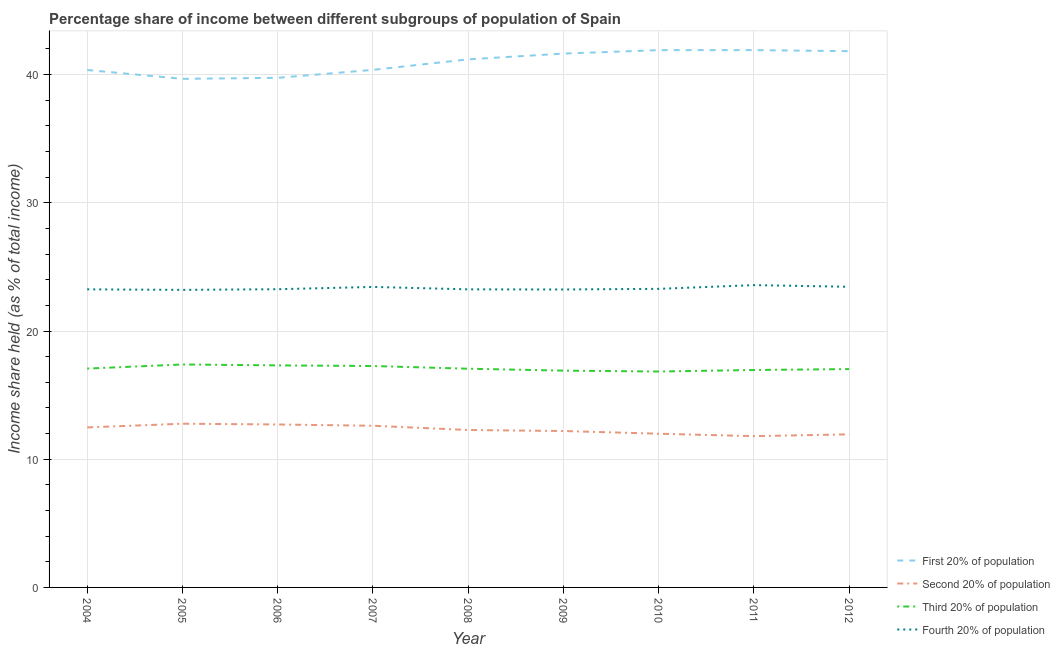Does the line corresponding to share of the income held by first 20% of the population intersect with the line corresponding to share of the income held by third 20% of the population?
Provide a short and direct response. No. Is the number of lines equal to the number of legend labels?
Ensure brevity in your answer.  Yes. What is the share of the income held by first 20% of the population in 2012?
Give a very brief answer. 41.83. Across all years, what is the maximum share of the income held by fourth 20% of the population?
Provide a short and direct response. 23.58. Across all years, what is the minimum share of the income held by third 20% of the population?
Offer a terse response. 16.84. In which year was the share of the income held by second 20% of the population maximum?
Offer a terse response. 2005. What is the total share of the income held by third 20% of the population in the graph?
Provide a succinct answer. 153.85. What is the difference between the share of the income held by first 20% of the population in 2007 and that in 2010?
Your response must be concise. -1.54. What is the difference between the share of the income held by third 20% of the population in 2008 and the share of the income held by first 20% of the population in 2010?
Provide a succinct answer. -24.85. What is the average share of the income held by third 20% of the population per year?
Offer a very short reply. 17.09. In the year 2011, what is the difference between the share of the income held by second 20% of the population and share of the income held by third 20% of the population?
Ensure brevity in your answer.  -5.16. In how many years, is the share of the income held by third 20% of the population greater than 4 %?
Provide a short and direct response. 9. What is the ratio of the share of the income held by third 20% of the population in 2004 to that in 2008?
Offer a very short reply. 1. Is the share of the income held by fourth 20% of the population in 2011 less than that in 2012?
Offer a very short reply. No. Is the difference between the share of the income held by second 20% of the population in 2006 and 2009 greater than the difference between the share of the income held by first 20% of the population in 2006 and 2009?
Your answer should be very brief. Yes. What is the difference between the highest and the second highest share of the income held by second 20% of the population?
Offer a terse response. 0.06. What is the difference between the highest and the lowest share of the income held by fourth 20% of the population?
Provide a succinct answer. 0.37. Is the sum of the share of the income held by first 20% of the population in 2006 and 2010 greater than the maximum share of the income held by third 20% of the population across all years?
Your answer should be very brief. Yes. Is it the case that in every year, the sum of the share of the income held by first 20% of the population and share of the income held by second 20% of the population is greater than the sum of share of the income held by fourth 20% of the population and share of the income held by third 20% of the population?
Keep it short and to the point. No. Does the share of the income held by third 20% of the population monotonically increase over the years?
Provide a succinct answer. No. How many lines are there?
Provide a short and direct response. 4. How many years are there in the graph?
Make the answer very short. 9. Does the graph contain any zero values?
Ensure brevity in your answer.  No. Does the graph contain grids?
Make the answer very short. Yes. Where does the legend appear in the graph?
Provide a short and direct response. Bottom right. What is the title of the graph?
Make the answer very short. Percentage share of income between different subgroups of population of Spain. What is the label or title of the X-axis?
Make the answer very short. Year. What is the label or title of the Y-axis?
Provide a succinct answer. Income share held (as % of total income). What is the Income share held (as % of total income) in First 20% of population in 2004?
Your answer should be very brief. 40.36. What is the Income share held (as % of total income) of Second 20% of population in 2004?
Keep it short and to the point. 12.48. What is the Income share held (as % of total income) in Third 20% of population in 2004?
Keep it short and to the point. 17.07. What is the Income share held (as % of total income) of Fourth 20% of population in 2004?
Provide a succinct answer. 23.25. What is the Income share held (as % of total income) in First 20% of population in 2005?
Keep it short and to the point. 39.67. What is the Income share held (as % of total income) of Second 20% of population in 2005?
Keep it short and to the point. 12.77. What is the Income share held (as % of total income) in Third 20% of population in 2005?
Offer a very short reply. 17.39. What is the Income share held (as % of total income) in Fourth 20% of population in 2005?
Make the answer very short. 23.21. What is the Income share held (as % of total income) in First 20% of population in 2006?
Your response must be concise. 39.75. What is the Income share held (as % of total income) of Second 20% of population in 2006?
Your answer should be very brief. 12.71. What is the Income share held (as % of total income) of Third 20% of population in 2006?
Your answer should be very brief. 17.32. What is the Income share held (as % of total income) of Fourth 20% of population in 2006?
Keep it short and to the point. 23.26. What is the Income share held (as % of total income) in First 20% of population in 2007?
Your answer should be compact. 40.37. What is the Income share held (as % of total income) of Second 20% of population in 2007?
Provide a short and direct response. 12.61. What is the Income share held (as % of total income) in Third 20% of population in 2007?
Provide a short and direct response. 17.27. What is the Income share held (as % of total income) of Fourth 20% of population in 2007?
Offer a terse response. 23.44. What is the Income share held (as % of total income) of First 20% of population in 2008?
Make the answer very short. 41.19. What is the Income share held (as % of total income) of Second 20% of population in 2008?
Provide a short and direct response. 12.28. What is the Income share held (as % of total income) of Third 20% of population in 2008?
Make the answer very short. 17.06. What is the Income share held (as % of total income) of Fourth 20% of population in 2008?
Keep it short and to the point. 23.25. What is the Income share held (as % of total income) of First 20% of population in 2009?
Offer a very short reply. 41.64. What is the Income share held (as % of total income) in Third 20% of population in 2009?
Your answer should be compact. 16.91. What is the Income share held (as % of total income) in Fourth 20% of population in 2009?
Offer a terse response. 23.24. What is the Income share held (as % of total income) in First 20% of population in 2010?
Your response must be concise. 41.91. What is the Income share held (as % of total income) of Second 20% of population in 2010?
Give a very brief answer. 11.99. What is the Income share held (as % of total income) in Third 20% of population in 2010?
Make the answer very short. 16.84. What is the Income share held (as % of total income) of Fourth 20% of population in 2010?
Offer a terse response. 23.29. What is the Income share held (as % of total income) of First 20% of population in 2011?
Your answer should be compact. 41.91. What is the Income share held (as % of total income) of Second 20% of population in 2011?
Make the answer very short. 11.8. What is the Income share held (as % of total income) of Third 20% of population in 2011?
Ensure brevity in your answer.  16.96. What is the Income share held (as % of total income) of Fourth 20% of population in 2011?
Make the answer very short. 23.58. What is the Income share held (as % of total income) of First 20% of population in 2012?
Keep it short and to the point. 41.83. What is the Income share held (as % of total income) of Second 20% of population in 2012?
Ensure brevity in your answer.  11.94. What is the Income share held (as % of total income) in Third 20% of population in 2012?
Your answer should be very brief. 17.03. What is the Income share held (as % of total income) in Fourth 20% of population in 2012?
Your answer should be very brief. 23.45. Across all years, what is the maximum Income share held (as % of total income) in First 20% of population?
Offer a very short reply. 41.91. Across all years, what is the maximum Income share held (as % of total income) of Second 20% of population?
Your answer should be compact. 12.77. Across all years, what is the maximum Income share held (as % of total income) of Third 20% of population?
Offer a very short reply. 17.39. Across all years, what is the maximum Income share held (as % of total income) in Fourth 20% of population?
Make the answer very short. 23.58. Across all years, what is the minimum Income share held (as % of total income) of First 20% of population?
Ensure brevity in your answer.  39.67. Across all years, what is the minimum Income share held (as % of total income) in Second 20% of population?
Your response must be concise. 11.8. Across all years, what is the minimum Income share held (as % of total income) in Third 20% of population?
Provide a succinct answer. 16.84. Across all years, what is the minimum Income share held (as % of total income) in Fourth 20% of population?
Keep it short and to the point. 23.21. What is the total Income share held (as % of total income) in First 20% of population in the graph?
Your response must be concise. 368.63. What is the total Income share held (as % of total income) in Second 20% of population in the graph?
Keep it short and to the point. 110.78. What is the total Income share held (as % of total income) of Third 20% of population in the graph?
Ensure brevity in your answer.  153.85. What is the total Income share held (as % of total income) of Fourth 20% of population in the graph?
Keep it short and to the point. 209.97. What is the difference between the Income share held (as % of total income) of First 20% of population in 2004 and that in 2005?
Your answer should be compact. 0.69. What is the difference between the Income share held (as % of total income) in Second 20% of population in 2004 and that in 2005?
Keep it short and to the point. -0.29. What is the difference between the Income share held (as % of total income) in Third 20% of population in 2004 and that in 2005?
Provide a succinct answer. -0.32. What is the difference between the Income share held (as % of total income) in First 20% of population in 2004 and that in 2006?
Keep it short and to the point. 0.61. What is the difference between the Income share held (as % of total income) in Second 20% of population in 2004 and that in 2006?
Provide a short and direct response. -0.23. What is the difference between the Income share held (as % of total income) in Fourth 20% of population in 2004 and that in 2006?
Offer a terse response. -0.01. What is the difference between the Income share held (as % of total income) of First 20% of population in 2004 and that in 2007?
Ensure brevity in your answer.  -0.01. What is the difference between the Income share held (as % of total income) in Second 20% of population in 2004 and that in 2007?
Keep it short and to the point. -0.13. What is the difference between the Income share held (as % of total income) in Third 20% of population in 2004 and that in 2007?
Provide a short and direct response. -0.2. What is the difference between the Income share held (as % of total income) of Fourth 20% of population in 2004 and that in 2007?
Your response must be concise. -0.19. What is the difference between the Income share held (as % of total income) of First 20% of population in 2004 and that in 2008?
Keep it short and to the point. -0.83. What is the difference between the Income share held (as % of total income) in First 20% of population in 2004 and that in 2009?
Your response must be concise. -1.28. What is the difference between the Income share held (as % of total income) in Second 20% of population in 2004 and that in 2009?
Your answer should be compact. 0.28. What is the difference between the Income share held (as % of total income) of Third 20% of population in 2004 and that in 2009?
Offer a very short reply. 0.16. What is the difference between the Income share held (as % of total income) of Fourth 20% of population in 2004 and that in 2009?
Offer a very short reply. 0.01. What is the difference between the Income share held (as % of total income) of First 20% of population in 2004 and that in 2010?
Offer a terse response. -1.55. What is the difference between the Income share held (as % of total income) in Second 20% of population in 2004 and that in 2010?
Your answer should be compact. 0.49. What is the difference between the Income share held (as % of total income) of Third 20% of population in 2004 and that in 2010?
Give a very brief answer. 0.23. What is the difference between the Income share held (as % of total income) of Fourth 20% of population in 2004 and that in 2010?
Keep it short and to the point. -0.04. What is the difference between the Income share held (as % of total income) of First 20% of population in 2004 and that in 2011?
Ensure brevity in your answer.  -1.55. What is the difference between the Income share held (as % of total income) of Second 20% of population in 2004 and that in 2011?
Your answer should be compact. 0.68. What is the difference between the Income share held (as % of total income) in Third 20% of population in 2004 and that in 2011?
Make the answer very short. 0.11. What is the difference between the Income share held (as % of total income) in Fourth 20% of population in 2004 and that in 2011?
Give a very brief answer. -0.33. What is the difference between the Income share held (as % of total income) in First 20% of population in 2004 and that in 2012?
Keep it short and to the point. -1.47. What is the difference between the Income share held (as % of total income) in Second 20% of population in 2004 and that in 2012?
Provide a short and direct response. 0.54. What is the difference between the Income share held (as % of total income) of Third 20% of population in 2004 and that in 2012?
Make the answer very short. 0.04. What is the difference between the Income share held (as % of total income) of First 20% of population in 2005 and that in 2006?
Your answer should be compact. -0.08. What is the difference between the Income share held (as % of total income) of Third 20% of population in 2005 and that in 2006?
Make the answer very short. 0.07. What is the difference between the Income share held (as % of total income) in Fourth 20% of population in 2005 and that in 2006?
Offer a very short reply. -0.05. What is the difference between the Income share held (as % of total income) in Second 20% of population in 2005 and that in 2007?
Ensure brevity in your answer.  0.16. What is the difference between the Income share held (as % of total income) in Third 20% of population in 2005 and that in 2007?
Your response must be concise. 0.12. What is the difference between the Income share held (as % of total income) in Fourth 20% of population in 2005 and that in 2007?
Your answer should be compact. -0.23. What is the difference between the Income share held (as % of total income) of First 20% of population in 2005 and that in 2008?
Provide a succinct answer. -1.52. What is the difference between the Income share held (as % of total income) of Second 20% of population in 2005 and that in 2008?
Offer a terse response. 0.49. What is the difference between the Income share held (as % of total income) of Third 20% of population in 2005 and that in 2008?
Keep it short and to the point. 0.33. What is the difference between the Income share held (as % of total income) of Fourth 20% of population in 2005 and that in 2008?
Your response must be concise. -0.04. What is the difference between the Income share held (as % of total income) in First 20% of population in 2005 and that in 2009?
Offer a terse response. -1.97. What is the difference between the Income share held (as % of total income) of Second 20% of population in 2005 and that in 2009?
Provide a succinct answer. 0.57. What is the difference between the Income share held (as % of total income) in Third 20% of population in 2005 and that in 2009?
Ensure brevity in your answer.  0.48. What is the difference between the Income share held (as % of total income) of Fourth 20% of population in 2005 and that in 2009?
Give a very brief answer. -0.03. What is the difference between the Income share held (as % of total income) of First 20% of population in 2005 and that in 2010?
Give a very brief answer. -2.24. What is the difference between the Income share held (as % of total income) of Second 20% of population in 2005 and that in 2010?
Offer a very short reply. 0.78. What is the difference between the Income share held (as % of total income) in Third 20% of population in 2005 and that in 2010?
Keep it short and to the point. 0.55. What is the difference between the Income share held (as % of total income) in Fourth 20% of population in 2005 and that in 2010?
Your answer should be very brief. -0.08. What is the difference between the Income share held (as % of total income) in First 20% of population in 2005 and that in 2011?
Provide a short and direct response. -2.24. What is the difference between the Income share held (as % of total income) in Third 20% of population in 2005 and that in 2011?
Give a very brief answer. 0.43. What is the difference between the Income share held (as % of total income) of Fourth 20% of population in 2005 and that in 2011?
Ensure brevity in your answer.  -0.37. What is the difference between the Income share held (as % of total income) of First 20% of population in 2005 and that in 2012?
Your answer should be compact. -2.16. What is the difference between the Income share held (as % of total income) in Second 20% of population in 2005 and that in 2012?
Make the answer very short. 0.83. What is the difference between the Income share held (as % of total income) in Third 20% of population in 2005 and that in 2012?
Give a very brief answer. 0.36. What is the difference between the Income share held (as % of total income) in Fourth 20% of population in 2005 and that in 2012?
Your answer should be compact. -0.24. What is the difference between the Income share held (as % of total income) in First 20% of population in 2006 and that in 2007?
Your answer should be compact. -0.62. What is the difference between the Income share held (as % of total income) in Third 20% of population in 2006 and that in 2007?
Your response must be concise. 0.05. What is the difference between the Income share held (as % of total income) of Fourth 20% of population in 2006 and that in 2007?
Your answer should be compact. -0.18. What is the difference between the Income share held (as % of total income) in First 20% of population in 2006 and that in 2008?
Ensure brevity in your answer.  -1.44. What is the difference between the Income share held (as % of total income) of Second 20% of population in 2006 and that in 2008?
Your answer should be compact. 0.43. What is the difference between the Income share held (as % of total income) in Third 20% of population in 2006 and that in 2008?
Your response must be concise. 0.26. What is the difference between the Income share held (as % of total income) of First 20% of population in 2006 and that in 2009?
Your response must be concise. -1.89. What is the difference between the Income share held (as % of total income) of Second 20% of population in 2006 and that in 2009?
Your response must be concise. 0.51. What is the difference between the Income share held (as % of total income) of Third 20% of population in 2006 and that in 2009?
Ensure brevity in your answer.  0.41. What is the difference between the Income share held (as % of total income) of Fourth 20% of population in 2006 and that in 2009?
Your answer should be compact. 0.02. What is the difference between the Income share held (as % of total income) of First 20% of population in 2006 and that in 2010?
Your answer should be very brief. -2.16. What is the difference between the Income share held (as % of total income) of Second 20% of population in 2006 and that in 2010?
Your answer should be very brief. 0.72. What is the difference between the Income share held (as % of total income) in Third 20% of population in 2006 and that in 2010?
Make the answer very short. 0.48. What is the difference between the Income share held (as % of total income) of Fourth 20% of population in 2006 and that in 2010?
Your answer should be compact. -0.03. What is the difference between the Income share held (as % of total income) of First 20% of population in 2006 and that in 2011?
Keep it short and to the point. -2.16. What is the difference between the Income share held (as % of total income) of Second 20% of population in 2006 and that in 2011?
Ensure brevity in your answer.  0.91. What is the difference between the Income share held (as % of total income) in Third 20% of population in 2006 and that in 2011?
Provide a succinct answer. 0.36. What is the difference between the Income share held (as % of total income) in Fourth 20% of population in 2006 and that in 2011?
Make the answer very short. -0.32. What is the difference between the Income share held (as % of total income) of First 20% of population in 2006 and that in 2012?
Provide a short and direct response. -2.08. What is the difference between the Income share held (as % of total income) in Second 20% of population in 2006 and that in 2012?
Offer a very short reply. 0.77. What is the difference between the Income share held (as % of total income) of Third 20% of population in 2006 and that in 2012?
Ensure brevity in your answer.  0.29. What is the difference between the Income share held (as % of total income) in Fourth 20% of population in 2006 and that in 2012?
Your answer should be very brief. -0.19. What is the difference between the Income share held (as % of total income) in First 20% of population in 2007 and that in 2008?
Offer a terse response. -0.82. What is the difference between the Income share held (as % of total income) in Second 20% of population in 2007 and that in 2008?
Your response must be concise. 0.33. What is the difference between the Income share held (as % of total income) of Third 20% of population in 2007 and that in 2008?
Ensure brevity in your answer.  0.21. What is the difference between the Income share held (as % of total income) of Fourth 20% of population in 2007 and that in 2008?
Make the answer very short. 0.19. What is the difference between the Income share held (as % of total income) in First 20% of population in 2007 and that in 2009?
Your answer should be compact. -1.27. What is the difference between the Income share held (as % of total income) in Second 20% of population in 2007 and that in 2009?
Your answer should be compact. 0.41. What is the difference between the Income share held (as % of total income) in Third 20% of population in 2007 and that in 2009?
Your answer should be compact. 0.36. What is the difference between the Income share held (as % of total income) of Fourth 20% of population in 2007 and that in 2009?
Your response must be concise. 0.2. What is the difference between the Income share held (as % of total income) of First 20% of population in 2007 and that in 2010?
Your answer should be very brief. -1.54. What is the difference between the Income share held (as % of total income) of Second 20% of population in 2007 and that in 2010?
Your answer should be compact. 0.62. What is the difference between the Income share held (as % of total income) of Third 20% of population in 2007 and that in 2010?
Your answer should be compact. 0.43. What is the difference between the Income share held (as % of total income) in Fourth 20% of population in 2007 and that in 2010?
Your answer should be very brief. 0.15. What is the difference between the Income share held (as % of total income) of First 20% of population in 2007 and that in 2011?
Offer a very short reply. -1.54. What is the difference between the Income share held (as % of total income) in Second 20% of population in 2007 and that in 2011?
Your answer should be compact. 0.81. What is the difference between the Income share held (as % of total income) in Third 20% of population in 2007 and that in 2011?
Your response must be concise. 0.31. What is the difference between the Income share held (as % of total income) of Fourth 20% of population in 2007 and that in 2011?
Offer a terse response. -0.14. What is the difference between the Income share held (as % of total income) in First 20% of population in 2007 and that in 2012?
Your response must be concise. -1.46. What is the difference between the Income share held (as % of total income) of Second 20% of population in 2007 and that in 2012?
Ensure brevity in your answer.  0.67. What is the difference between the Income share held (as % of total income) of Third 20% of population in 2007 and that in 2012?
Your answer should be very brief. 0.24. What is the difference between the Income share held (as % of total income) in Fourth 20% of population in 2007 and that in 2012?
Make the answer very short. -0.01. What is the difference between the Income share held (as % of total income) of First 20% of population in 2008 and that in 2009?
Make the answer very short. -0.45. What is the difference between the Income share held (as % of total income) of Third 20% of population in 2008 and that in 2009?
Your answer should be very brief. 0.15. What is the difference between the Income share held (as % of total income) in Fourth 20% of population in 2008 and that in 2009?
Give a very brief answer. 0.01. What is the difference between the Income share held (as % of total income) in First 20% of population in 2008 and that in 2010?
Offer a very short reply. -0.72. What is the difference between the Income share held (as % of total income) in Second 20% of population in 2008 and that in 2010?
Your answer should be very brief. 0.29. What is the difference between the Income share held (as % of total income) of Third 20% of population in 2008 and that in 2010?
Keep it short and to the point. 0.22. What is the difference between the Income share held (as % of total income) of Fourth 20% of population in 2008 and that in 2010?
Offer a very short reply. -0.04. What is the difference between the Income share held (as % of total income) in First 20% of population in 2008 and that in 2011?
Make the answer very short. -0.72. What is the difference between the Income share held (as % of total income) of Second 20% of population in 2008 and that in 2011?
Your answer should be compact. 0.48. What is the difference between the Income share held (as % of total income) in Fourth 20% of population in 2008 and that in 2011?
Your answer should be compact. -0.33. What is the difference between the Income share held (as % of total income) in First 20% of population in 2008 and that in 2012?
Give a very brief answer. -0.64. What is the difference between the Income share held (as % of total income) of Second 20% of population in 2008 and that in 2012?
Keep it short and to the point. 0.34. What is the difference between the Income share held (as % of total income) of Third 20% of population in 2008 and that in 2012?
Keep it short and to the point. 0.03. What is the difference between the Income share held (as % of total income) in Fourth 20% of population in 2008 and that in 2012?
Provide a succinct answer. -0.2. What is the difference between the Income share held (as % of total income) of First 20% of population in 2009 and that in 2010?
Make the answer very short. -0.27. What is the difference between the Income share held (as % of total income) in Second 20% of population in 2009 and that in 2010?
Provide a succinct answer. 0.21. What is the difference between the Income share held (as % of total income) of Third 20% of population in 2009 and that in 2010?
Your response must be concise. 0.07. What is the difference between the Income share held (as % of total income) of First 20% of population in 2009 and that in 2011?
Make the answer very short. -0.27. What is the difference between the Income share held (as % of total income) of Fourth 20% of population in 2009 and that in 2011?
Offer a very short reply. -0.34. What is the difference between the Income share held (as % of total income) in First 20% of population in 2009 and that in 2012?
Offer a terse response. -0.19. What is the difference between the Income share held (as % of total income) of Second 20% of population in 2009 and that in 2012?
Your answer should be compact. 0.26. What is the difference between the Income share held (as % of total income) of Third 20% of population in 2009 and that in 2012?
Ensure brevity in your answer.  -0.12. What is the difference between the Income share held (as % of total income) of Fourth 20% of population in 2009 and that in 2012?
Your answer should be compact. -0.21. What is the difference between the Income share held (as % of total income) of Second 20% of population in 2010 and that in 2011?
Your answer should be very brief. 0.19. What is the difference between the Income share held (as % of total income) in Third 20% of population in 2010 and that in 2011?
Provide a short and direct response. -0.12. What is the difference between the Income share held (as % of total income) in Fourth 20% of population in 2010 and that in 2011?
Offer a very short reply. -0.29. What is the difference between the Income share held (as % of total income) in Second 20% of population in 2010 and that in 2012?
Your answer should be compact. 0.05. What is the difference between the Income share held (as % of total income) of Third 20% of population in 2010 and that in 2012?
Ensure brevity in your answer.  -0.19. What is the difference between the Income share held (as % of total income) of Fourth 20% of population in 2010 and that in 2012?
Provide a succinct answer. -0.16. What is the difference between the Income share held (as % of total income) of Second 20% of population in 2011 and that in 2012?
Your answer should be compact. -0.14. What is the difference between the Income share held (as % of total income) in Third 20% of population in 2011 and that in 2012?
Provide a short and direct response. -0.07. What is the difference between the Income share held (as % of total income) in Fourth 20% of population in 2011 and that in 2012?
Provide a short and direct response. 0.13. What is the difference between the Income share held (as % of total income) in First 20% of population in 2004 and the Income share held (as % of total income) in Second 20% of population in 2005?
Provide a short and direct response. 27.59. What is the difference between the Income share held (as % of total income) in First 20% of population in 2004 and the Income share held (as % of total income) in Third 20% of population in 2005?
Your answer should be very brief. 22.97. What is the difference between the Income share held (as % of total income) in First 20% of population in 2004 and the Income share held (as % of total income) in Fourth 20% of population in 2005?
Your answer should be very brief. 17.15. What is the difference between the Income share held (as % of total income) of Second 20% of population in 2004 and the Income share held (as % of total income) of Third 20% of population in 2005?
Give a very brief answer. -4.91. What is the difference between the Income share held (as % of total income) of Second 20% of population in 2004 and the Income share held (as % of total income) of Fourth 20% of population in 2005?
Keep it short and to the point. -10.73. What is the difference between the Income share held (as % of total income) of Third 20% of population in 2004 and the Income share held (as % of total income) of Fourth 20% of population in 2005?
Provide a succinct answer. -6.14. What is the difference between the Income share held (as % of total income) of First 20% of population in 2004 and the Income share held (as % of total income) of Second 20% of population in 2006?
Ensure brevity in your answer.  27.65. What is the difference between the Income share held (as % of total income) in First 20% of population in 2004 and the Income share held (as % of total income) in Third 20% of population in 2006?
Ensure brevity in your answer.  23.04. What is the difference between the Income share held (as % of total income) in Second 20% of population in 2004 and the Income share held (as % of total income) in Third 20% of population in 2006?
Your response must be concise. -4.84. What is the difference between the Income share held (as % of total income) in Second 20% of population in 2004 and the Income share held (as % of total income) in Fourth 20% of population in 2006?
Ensure brevity in your answer.  -10.78. What is the difference between the Income share held (as % of total income) in Third 20% of population in 2004 and the Income share held (as % of total income) in Fourth 20% of population in 2006?
Your answer should be compact. -6.19. What is the difference between the Income share held (as % of total income) of First 20% of population in 2004 and the Income share held (as % of total income) of Second 20% of population in 2007?
Make the answer very short. 27.75. What is the difference between the Income share held (as % of total income) of First 20% of population in 2004 and the Income share held (as % of total income) of Third 20% of population in 2007?
Your answer should be compact. 23.09. What is the difference between the Income share held (as % of total income) of First 20% of population in 2004 and the Income share held (as % of total income) of Fourth 20% of population in 2007?
Offer a terse response. 16.92. What is the difference between the Income share held (as % of total income) of Second 20% of population in 2004 and the Income share held (as % of total income) of Third 20% of population in 2007?
Offer a very short reply. -4.79. What is the difference between the Income share held (as % of total income) of Second 20% of population in 2004 and the Income share held (as % of total income) of Fourth 20% of population in 2007?
Provide a succinct answer. -10.96. What is the difference between the Income share held (as % of total income) in Third 20% of population in 2004 and the Income share held (as % of total income) in Fourth 20% of population in 2007?
Offer a terse response. -6.37. What is the difference between the Income share held (as % of total income) of First 20% of population in 2004 and the Income share held (as % of total income) of Second 20% of population in 2008?
Your answer should be compact. 28.08. What is the difference between the Income share held (as % of total income) in First 20% of population in 2004 and the Income share held (as % of total income) in Third 20% of population in 2008?
Ensure brevity in your answer.  23.3. What is the difference between the Income share held (as % of total income) in First 20% of population in 2004 and the Income share held (as % of total income) in Fourth 20% of population in 2008?
Offer a very short reply. 17.11. What is the difference between the Income share held (as % of total income) in Second 20% of population in 2004 and the Income share held (as % of total income) in Third 20% of population in 2008?
Your response must be concise. -4.58. What is the difference between the Income share held (as % of total income) of Second 20% of population in 2004 and the Income share held (as % of total income) of Fourth 20% of population in 2008?
Your answer should be very brief. -10.77. What is the difference between the Income share held (as % of total income) of Third 20% of population in 2004 and the Income share held (as % of total income) of Fourth 20% of population in 2008?
Give a very brief answer. -6.18. What is the difference between the Income share held (as % of total income) of First 20% of population in 2004 and the Income share held (as % of total income) of Second 20% of population in 2009?
Ensure brevity in your answer.  28.16. What is the difference between the Income share held (as % of total income) of First 20% of population in 2004 and the Income share held (as % of total income) of Third 20% of population in 2009?
Your response must be concise. 23.45. What is the difference between the Income share held (as % of total income) of First 20% of population in 2004 and the Income share held (as % of total income) of Fourth 20% of population in 2009?
Your answer should be very brief. 17.12. What is the difference between the Income share held (as % of total income) of Second 20% of population in 2004 and the Income share held (as % of total income) of Third 20% of population in 2009?
Your answer should be very brief. -4.43. What is the difference between the Income share held (as % of total income) of Second 20% of population in 2004 and the Income share held (as % of total income) of Fourth 20% of population in 2009?
Your answer should be compact. -10.76. What is the difference between the Income share held (as % of total income) of Third 20% of population in 2004 and the Income share held (as % of total income) of Fourth 20% of population in 2009?
Provide a succinct answer. -6.17. What is the difference between the Income share held (as % of total income) in First 20% of population in 2004 and the Income share held (as % of total income) in Second 20% of population in 2010?
Your response must be concise. 28.37. What is the difference between the Income share held (as % of total income) in First 20% of population in 2004 and the Income share held (as % of total income) in Third 20% of population in 2010?
Ensure brevity in your answer.  23.52. What is the difference between the Income share held (as % of total income) in First 20% of population in 2004 and the Income share held (as % of total income) in Fourth 20% of population in 2010?
Your answer should be compact. 17.07. What is the difference between the Income share held (as % of total income) of Second 20% of population in 2004 and the Income share held (as % of total income) of Third 20% of population in 2010?
Your response must be concise. -4.36. What is the difference between the Income share held (as % of total income) of Second 20% of population in 2004 and the Income share held (as % of total income) of Fourth 20% of population in 2010?
Give a very brief answer. -10.81. What is the difference between the Income share held (as % of total income) of Third 20% of population in 2004 and the Income share held (as % of total income) of Fourth 20% of population in 2010?
Offer a terse response. -6.22. What is the difference between the Income share held (as % of total income) in First 20% of population in 2004 and the Income share held (as % of total income) in Second 20% of population in 2011?
Give a very brief answer. 28.56. What is the difference between the Income share held (as % of total income) in First 20% of population in 2004 and the Income share held (as % of total income) in Third 20% of population in 2011?
Your answer should be compact. 23.4. What is the difference between the Income share held (as % of total income) of First 20% of population in 2004 and the Income share held (as % of total income) of Fourth 20% of population in 2011?
Your answer should be compact. 16.78. What is the difference between the Income share held (as % of total income) of Second 20% of population in 2004 and the Income share held (as % of total income) of Third 20% of population in 2011?
Offer a terse response. -4.48. What is the difference between the Income share held (as % of total income) in Third 20% of population in 2004 and the Income share held (as % of total income) in Fourth 20% of population in 2011?
Your answer should be very brief. -6.51. What is the difference between the Income share held (as % of total income) in First 20% of population in 2004 and the Income share held (as % of total income) in Second 20% of population in 2012?
Offer a terse response. 28.42. What is the difference between the Income share held (as % of total income) in First 20% of population in 2004 and the Income share held (as % of total income) in Third 20% of population in 2012?
Provide a short and direct response. 23.33. What is the difference between the Income share held (as % of total income) in First 20% of population in 2004 and the Income share held (as % of total income) in Fourth 20% of population in 2012?
Your answer should be very brief. 16.91. What is the difference between the Income share held (as % of total income) in Second 20% of population in 2004 and the Income share held (as % of total income) in Third 20% of population in 2012?
Make the answer very short. -4.55. What is the difference between the Income share held (as % of total income) of Second 20% of population in 2004 and the Income share held (as % of total income) of Fourth 20% of population in 2012?
Your answer should be very brief. -10.97. What is the difference between the Income share held (as % of total income) in Third 20% of population in 2004 and the Income share held (as % of total income) in Fourth 20% of population in 2012?
Offer a very short reply. -6.38. What is the difference between the Income share held (as % of total income) of First 20% of population in 2005 and the Income share held (as % of total income) of Second 20% of population in 2006?
Your answer should be compact. 26.96. What is the difference between the Income share held (as % of total income) in First 20% of population in 2005 and the Income share held (as % of total income) in Third 20% of population in 2006?
Keep it short and to the point. 22.35. What is the difference between the Income share held (as % of total income) in First 20% of population in 2005 and the Income share held (as % of total income) in Fourth 20% of population in 2006?
Ensure brevity in your answer.  16.41. What is the difference between the Income share held (as % of total income) in Second 20% of population in 2005 and the Income share held (as % of total income) in Third 20% of population in 2006?
Your answer should be very brief. -4.55. What is the difference between the Income share held (as % of total income) of Second 20% of population in 2005 and the Income share held (as % of total income) of Fourth 20% of population in 2006?
Provide a short and direct response. -10.49. What is the difference between the Income share held (as % of total income) of Third 20% of population in 2005 and the Income share held (as % of total income) of Fourth 20% of population in 2006?
Offer a terse response. -5.87. What is the difference between the Income share held (as % of total income) in First 20% of population in 2005 and the Income share held (as % of total income) in Second 20% of population in 2007?
Your answer should be compact. 27.06. What is the difference between the Income share held (as % of total income) of First 20% of population in 2005 and the Income share held (as % of total income) of Third 20% of population in 2007?
Your answer should be compact. 22.4. What is the difference between the Income share held (as % of total income) in First 20% of population in 2005 and the Income share held (as % of total income) in Fourth 20% of population in 2007?
Your answer should be compact. 16.23. What is the difference between the Income share held (as % of total income) in Second 20% of population in 2005 and the Income share held (as % of total income) in Third 20% of population in 2007?
Your response must be concise. -4.5. What is the difference between the Income share held (as % of total income) in Second 20% of population in 2005 and the Income share held (as % of total income) in Fourth 20% of population in 2007?
Make the answer very short. -10.67. What is the difference between the Income share held (as % of total income) of Third 20% of population in 2005 and the Income share held (as % of total income) of Fourth 20% of population in 2007?
Offer a very short reply. -6.05. What is the difference between the Income share held (as % of total income) in First 20% of population in 2005 and the Income share held (as % of total income) in Second 20% of population in 2008?
Ensure brevity in your answer.  27.39. What is the difference between the Income share held (as % of total income) of First 20% of population in 2005 and the Income share held (as % of total income) of Third 20% of population in 2008?
Offer a terse response. 22.61. What is the difference between the Income share held (as % of total income) of First 20% of population in 2005 and the Income share held (as % of total income) of Fourth 20% of population in 2008?
Give a very brief answer. 16.42. What is the difference between the Income share held (as % of total income) in Second 20% of population in 2005 and the Income share held (as % of total income) in Third 20% of population in 2008?
Your answer should be compact. -4.29. What is the difference between the Income share held (as % of total income) in Second 20% of population in 2005 and the Income share held (as % of total income) in Fourth 20% of population in 2008?
Provide a short and direct response. -10.48. What is the difference between the Income share held (as % of total income) in Third 20% of population in 2005 and the Income share held (as % of total income) in Fourth 20% of population in 2008?
Ensure brevity in your answer.  -5.86. What is the difference between the Income share held (as % of total income) in First 20% of population in 2005 and the Income share held (as % of total income) in Second 20% of population in 2009?
Ensure brevity in your answer.  27.47. What is the difference between the Income share held (as % of total income) in First 20% of population in 2005 and the Income share held (as % of total income) in Third 20% of population in 2009?
Your response must be concise. 22.76. What is the difference between the Income share held (as % of total income) of First 20% of population in 2005 and the Income share held (as % of total income) of Fourth 20% of population in 2009?
Provide a succinct answer. 16.43. What is the difference between the Income share held (as % of total income) of Second 20% of population in 2005 and the Income share held (as % of total income) of Third 20% of population in 2009?
Make the answer very short. -4.14. What is the difference between the Income share held (as % of total income) of Second 20% of population in 2005 and the Income share held (as % of total income) of Fourth 20% of population in 2009?
Offer a very short reply. -10.47. What is the difference between the Income share held (as % of total income) in Third 20% of population in 2005 and the Income share held (as % of total income) in Fourth 20% of population in 2009?
Offer a very short reply. -5.85. What is the difference between the Income share held (as % of total income) in First 20% of population in 2005 and the Income share held (as % of total income) in Second 20% of population in 2010?
Offer a terse response. 27.68. What is the difference between the Income share held (as % of total income) in First 20% of population in 2005 and the Income share held (as % of total income) in Third 20% of population in 2010?
Your answer should be very brief. 22.83. What is the difference between the Income share held (as % of total income) of First 20% of population in 2005 and the Income share held (as % of total income) of Fourth 20% of population in 2010?
Provide a succinct answer. 16.38. What is the difference between the Income share held (as % of total income) in Second 20% of population in 2005 and the Income share held (as % of total income) in Third 20% of population in 2010?
Offer a terse response. -4.07. What is the difference between the Income share held (as % of total income) of Second 20% of population in 2005 and the Income share held (as % of total income) of Fourth 20% of population in 2010?
Provide a succinct answer. -10.52. What is the difference between the Income share held (as % of total income) of Third 20% of population in 2005 and the Income share held (as % of total income) of Fourth 20% of population in 2010?
Make the answer very short. -5.9. What is the difference between the Income share held (as % of total income) of First 20% of population in 2005 and the Income share held (as % of total income) of Second 20% of population in 2011?
Your answer should be very brief. 27.87. What is the difference between the Income share held (as % of total income) of First 20% of population in 2005 and the Income share held (as % of total income) of Third 20% of population in 2011?
Give a very brief answer. 22.71. What is the difference between the Income share held (as % of total income) in First 20% of population in 2005 and the Income share held (as % of total income) in Fourth 20% of population in 2011?
Give a very brief answer. 16.09. What is the difference between the Income share held (as % of total income) in Second 20% of population in 2005 and the Income share held (as % of total income) in Third 20% of population in 2011?
Give a very brief answer. -4.19. What is the difference between the Income share held (as % of total income) of Second 20% of population in 2005 and the Income share held (as % of total income) of Fourth 20% of population in 2011?
Your response must be concise. -10.81. What is the difference between the Income share held (as % of total income) in Third 20% of population in 2005 and the Income share held (as % of total income) in Fourth 20% of population in 2011?
Give a very brief answer. -6.19. What is the difference between the Income share held (as % of total income) in First 20% of population in 2005 and the Income share held (as % of total income) in Second 20% of population in 2012?
Your answer should be compact. 27.73. What is the difference between the Income share held (as % of total income) in First 20% of population in 2005 and the Income share held (as % of total income) in Third 20% of population in 2012?
Your answer should be compact. 22.64. What is the difference between the Income share held (as % of total income) of First 20% of population in 2005 and the Income share held (as % of total income) of Fourth 20% of population in 2012?
Offer a terse response. 16.22. What is the difference between the Income share held (as % of total income) in Second 20% of population in 2005 and the Income share held (as % of total income) in Third 20% of population in 2012?
Make the answer very short. -4.26. What is the difference between the Income share held (as % of total income) in Second 20% of population in 2005 and the Income share held (as % of total income) in Fourth 20% of population in 2012?
Give a very brief answer. -10.68. What is the difference between the Income share held (as % of total income) of Third 20% of population in 2005 and the Income share held (as % of total income) of Fourth 20% of population in 2012?
Your response must be concise. -6.06. What is the difference between the Income share held (as % of total income) in First 20% of population in 2006 and the Income share held (as % of total income) in Second 20% of population in 2007?
Your response must be concise. 27.14. What is the difference between the Income share held (as % of total income) in First 20% of population in 2006 and the Income share held (as % of total income) in Third 20% of population in 2007?
Ensure brevity in your answer.  22.48. What is the difference between the Income share held (as % of total income) of First 20% of population in 2006 and the Income share held (as % of total income) of Fourth 20% of population in 2007?
Keep it short and to the point. 16.31. What is the difference between the Income share held (as % of total income) in Second 20% of population in 2006 and the Income share held (as % of total income) in Third 20% of population in 2007?
Ensure brevity in your answer.  -4.56. What is the difference between the Income share held (as % of total income) of Second 20% of population in 2006 and the Income share held (as % of total income) of Fourth 20% of population in 2007?
Your answer should be very brief. -10.73. What is the difference between the Income share held (as % of total income) in Third 20% of population in 2006 and the Income share held (as % of total income) in Fourth 20% of population in 2007?
Keep it short and to the point. -6.12. What is the difference between the Income share held (as % of total income) of First 20% of population in 2006 and the Income share held (as % of total income) of Second 20% of population in 2008?
Ensure brevity in your answer.  27.47. What is the difference between the Income share held (as % of total income) in First 20% of population in 2006 and the Income share held (as % of total income) in Third 20% of population in 2008?
Provide a short and direct response. 22.69. What is the difference between the Income share held (as % of total income) in Second 20% of population in 2006 and the Income share held (as % of total income) in Third 20% of population in 2008?
Ensure brevity in your answer.  -4.35. What is the difference between the Income share held (as % of total income) in Second 20% of population in 2006 and the Income share held (as % of total income) in Fourth 20% of population in 2008?
Provide a short and direct response. -10.54. What is the difference between the Income share held (as % of total income) in Third 20% of population in 2006 and the Income share held (as % of total income) in Fourth 20% of population in 2008?
Give a very brief answer. -5.93. What is the difference between the Income share held (as % of total income) of First 20% of population in 2006 and the Income share held (as % of total income) of Second 20% of population in 2009?
Ensure brevity in your answer.  27.55. What is the difference between the Income share held (as % of total income) of First 20% of population in 2006 and the Income share held (as % of total income) of Third 20% of population in 2009?
Offer a very short reply. 22.84. What is the difference between the Income share held (as % of total income) of First 20% of population in 2006 and the Income share held (as % of total income) of Fourth 20% of population in 2009?
Make the answer very short. 16.51. What is the difference between the Income share held (as % of total income) of Second 20% of population in 2006 and the Income share held (as % of total income) of Third 20% of population in 2009?
Your response must be concise. -4.2. What is the difference between the Income share held (as % of total income) of Second 20% of population in 2006 and the Income share held (as % of total income) of Fourth 20% of population in 2009?
Provide a succinct answer. -10.53. What is the difference between the Income share held (as % of total income) of Third 20% of population in 2006 and the Income share held (as % of total income) of Fourth 20% of population in 2009?
Offer a very short reply. -5.92. What is the difference between the Income share held (as % of total income) in First 20% of population in 2006 and the Income share held (as % of total income) in Second 20% of population in 2010?
Your answer should be compact. 27.76. What is the difference between the Income share held (as % of total income) of First 20% of population in 2006 and the Income share held (as % of total income) of Third 20% of population in 2010?
Offer a very short reply. 22.91. What is the difference between the Income share held (as % of total income) in First 20% of population in 2006 and the Income share held (as % of total income) in Fourth 20% of population in 2010?
Offer a terse response. 16.46. What is the difference between the Income share held (as % of total income) of Second 20% of population in 2006 and the Income share held (as % of total income) of Third 20% of population in 2010?
Provide a short and direct response. -4.13. What is the difference between the Income share held (as % of total income) in Second 20% of population in 2006 and the Income share held (as % of total income) in Fourth 20% of population in 2010?
Provide a short and direct response. -10.58. What is the difference between the Income share held (as % of total income) of Third 20% of population in 2006 and the Income share held (as % of total income) of Fourth 20% of population in 2010?
Offer a very short reply. -5.97. What is the difference between the Income share held (as % of total income) of First 20% of population in 2006 and the Income share held (as % of total income) of Second 20% of population in 2011?
Your response must be concise. 27.95. What is the difference between the Income share held (as % of total income) of First 20% of population in 2006 and the Income share held (as % of total income) of Third 20% of population in 2011?
Give a very brief answer. 22.79. What is the difference between the Income share held (as % of total income) in First 20% of population in 2006 and the Income share held (as % of total income) in Fourth 20% of population in 2011?
Offer a very short reply. 16.17. What is the difference between the Income share held (as % of total income) of Second 20% of population in 2006 and the Income share held (as % of total income) of Third 20% of population in 2011?
Provide a short and direct response. -4.25. What is the difference between the Income share held (as % of total income) in Second 20% of population in 2006 and the Income share held (as % of total income) in Fourth 20% of population in 2011?
Ensure brevity in your answer.  -10.87. What is the difference between the Income share held (as % of total income) of Third 20% of population in 2006 and the Income share held (as % of total income) of Fourth 20% of population in 2011?
Your response must be concise. -6.26. What is the difference between the Income share held (as % of total income) of First 20% of population in 2006 and the Income share held (as % of total income) of Second 20% of population in 2012?
Keep it short and to the point. 27.81. What is the difference between the Income share held (as % of total income) of First 20% of population in 2006 and the Income share held (as % of total income) of Third 20% of population in 2012?
Provide a succinct answer. 22.72. What is the difference between the Income share held (as % of total income) in First 20% of population in 2006 and the Income share held (as % of total income) in Fourth 20% of population in 2012?
Ensure brevity in your answer.  16.3. What is the difference between the Income share held (as % of total income) of Second 20% of population in 2006 and the Income share held (as % of total income) of Third 20% of population in 2012?
Your answer should be compact. -4.32. What is the difference between the Income share held (as % of total income) in Second 20% of population in 2006 and the Income share held (as % of total income) in Fourth 20% of population in 2012?
Provide a short and direct response. -10.74. What is the difference between the Income share held (as % of total income) of Third 20% of population in 2006 and the Income share held (as % of total income) of Fourth 20% of population in 2012?
Your answer should be compact. -6.13. What is the difference between the Income share held (as % of total income) of First 20% of population in 2007 and the Income share held (as % of total income) of Second 20% of population in 2008?
Offer a very short reply. 28.09. What is the difference between the Income share held (as % of total income) of First 20% of population in 2007 and the Income share held (as % of total income) of Third 20% of population in 2008?
Provide a succinct answer. 23.31. What is the difference between the Income share held (as % of total income) of First 20% of population in 2007 and the Income share held (as % of total income) of Fourth 20% of population in 2008?
Provide a succinct answer. 17.12. What is the difference between the Income share held (as % of total income) of Second 20% of population in 2007 and the Income share held (as % of total income) of Third 20% of population in 2008?
Provide a succinct answer. -4.45. What is the difference between the Income share held (as % of total income) in Second 20% of population in 2007 and the Income share held (as % of total income) in Fourth 20% of population in 2008?
Offer a very short reply. -10.64. What is the difference between the Income share held (as % of total income) in Third 20% of population in 2007 and the Income share held (as % of total income) in Fourth 20% of population in 2008?
Offer a terse response. -5.98. What is the difference between the Income share held (as % of total income) of First 20% of population in 2007 and the Income share held (as % of total income) of Second 20% of population in 2009?
Keep it short and to the point. 28.17. What is the difference between the Income share held (as % of total income) in First 20% of population in 2007 and the Income share held (as % of total income) in Third 20% of population in 2009?
Your answer should be very brief. 23.46. What is the difference between the Income share held (as % of total income) of First 20% of population in 2007 and the Income share held (as % of total income) of Fourth 20% of population in 2009?
Offer a very short reply. 17.13. What is the difference between the Income share held (as % of total income) in Second 20% of population in 2007 and the Income share held (as % of total income) in Third 20% of population in 2009?
Offer a terse response. -4.3. What is the difference between the Income share held (as % of total income) in Second 20% of population in 2007 and the Income share held (as % of total income) in Fourth 20% of population in 2009?
Make the answer very short. -10.63. What is the difference between the Income share held (as % of total income) in Third 20% of population in 2007 and the Income share held (as % of total income) in Fourth 20% of population in 2009?
Keep it short and to the point. -5.97. What is the difference between the Income share held (as % of total income) of First 20% of population in 2007 and the Income share held (as % of total income) of Second 20% of population in 2010?
Offer a very short reply. 28.38. What is the difference between the Income share held (as % of total income) in First 20% of population in 2007 and the Income share held (as % of total income) in Third 20% of population in 2010?
Make the answer very short. 23.53. What is the difference between the Income share held (as % of total income) of First 20% of population in 2007 and the Income share held (as % of total income) of Fourth 20% of population in 2010?
Provide a short and direct response. 17.08. What is the difference between the Income share held (as % of total income) of Second 20% of population in 2007 and the Income share held (as % of total income) of Third 20% of population in 2010?
Ensure brevity in your answer.  -4.23. What is the difference between the Income share held (as % of total income) in Second 20% of population in 2007 and the Income share held (as % of total income) in Fourth 20% of population in 2010?
Your answer should be very brief. -10.68. What is the difference between the Income share held (as % of total income) of Third 20% of population in 2007 and the Income share held (as % of total income) of Fourth 20% of population in 2010?
Make the answer very short. -6.02. What is the difference between the Income share held (as % of total income) of First 20% of population in 2007 and the Income share held (as % of total income) of Second 20% of population in 2011?
Offer a terse response. 28.57. What is the difference between the Income share held (as % of total income) of First 20% of population in 2007 and the Income share held (as % of total income) of Third 20% of population in 2011?
Keep it short and to the point. 23.41. What is the difference between the Income share held (as % of total income) in First 20% of population in 2007 and the Income share held (as % of total income) in Fourth 20% of population in 2011?
Keep it short and to the point. 16.79. What is the difference between the Income share held (as % of total income) in Second 20% of population in 2007 and the Income share held (as % of total income) in Third 20% of population in 2011?
Make the answer very short. -4.35. What is the difference between the Income share held (as % of total income) in Second 20% of population in 2007 and the Income share held (as % of total income) in Fourth 20% of population in 2011?
Offer a terse response. -10.97. What is the difference between the Income share held (as % of total income) in Third 20% of population in 2007 and the Income share held (as % of total income) in Fourth 20% of population in 2011?
Your answer should be compact. -6.31. What is the difference between the Income share held (as % of total income) in First 20% of population in 2007 and the Income share held (as % of total income) in Second 20% of population in 2012?
Give a very brief answer. 28.43. What is the difference between the Income share held (as % of total income) in First 20% of population in 2007 and the Income share held (as % of total income) in Third 20% of population in 2012?
Your answer should be very brief. 23.34. What is the difference between the Income share held (as % of total income) of First 20% of population in 2007 and the Income share held (as % of total income) of Fourth 20% of population in 2012?
Your answer should be very brief. 16.92. What is the difference between the Income share held (as % of total income) in Second 20% of population in 2007 and the Income share held (as % of total income) in Third 20% of population in 2012?
Your response must be concise. -4.42. What is the difference between the Income share held (as % of total income) in Second 20% of population in 2007 and the Income share held (as % of total income) in Fourth 20% of population in 2012?
Keep it short and to the point. -10.84. What is the difference between the Income share held (as % of total income) of Third 20% of population in 2007 and the Income share held (as % of total income) of Fourth 20% of population in 2012?
Ensure brevity in your answer.  -6.18. What is the difference between the Income share held (as % of total income) of First 20% of population in 2008 and the Income share held (as % of total income) of Second 20% of population in 2009?
Provide a succinct answer. 28.99. What is the difference between the Income share held (as % of total income) in First 20% of population in 2008 and the Income share held (as % of total income) in Third 20% of population in 2009?
Your answer should be very brief. 24.28. What is the difference between the Income share held (as % of total income) in First 20% of population in 2008 and the Income share held (as % of total income) in Fourth 20% of population in 2009?
Ensure brevity in your answer.  17.95. What is the difference between the Income share held (as % of total income) of Second 20% of population in 2008 and the Income share held (as % of total income) of Third 20% of population in 2009?
Give a very brief answer. -4.63. What is the difference between the Income share held (as % of total income) in Second 20% of population in 2008 and the Income share held (as % of total income) in Fourth 20% of population in 2009?
Your response must be concise. -10.96. What is the difference between the Income share held (as % of total income) in Third 20% of population in 2008 and the Income share held (as % of total income) in Fourth 20% of population in 2009?
Keep it short and to the point. -6.18. What is the difference between the Income share held (as % of total income) of First 20% of population in 2008 and the Income share held (as % of total income) of Second 20% of population in 2010?
Ensure brevity in your answer.  29.2. What is the difference between the Income share held (as % of total income) of First 20% of population in 2008 and the Income share held (as % of total income) of Third 20% of population in 2010?
Ensure brevity in your answer.  24.35. What is the difference between the Income share held (as % of total income) in First 20% of population in 2008 and the Income share held (as % of total income) in Fourth 20% of population in 2010?
Your answer should be very brief. 17.9. What is the difference between the Income share held (as % of total income) of Second 20% of population in 2008 and the Income share held (as % of total income) of Third 20% of population in 2010?
Give a very brief answer. -4.56. What is the difference between the Income share held (as % of total income) in Second 20% of population in 2008 and the Income share held (as % of total income) in Fourth 20% of population in 2010?
Your answer should be very brief. -11.01. What is the difference between the Income share held (as % of total income) of Third 20% of population in 2008 and the Income share held (as % of total income) of Fourth 20% of population in 2010?
Provide a short and direct response. -6.23. What is the difference between the Income share held (as % of total income) in First 20% of population in 2008 and the Income share held (as % of total income) in Second 20% of population in 2011?
Provide a short and direct response. 29.39. What is the difference between the Income share held (as % of total income) of First 20% of population in 2008 and the Income share held (as % of total income) of Third 20% of population in 2011?
Provide a short and direct response. 24.23. What is the difference between the Income share held (as % of total income) of First 20% of population in 2008 and the Income share held (as % of total income) of Fourth 20% of population in 2011?
Your answer should be very brief. 17.61. What is the difference between the Income share held (as % of total income) in Second 20% of population in 2008 and the Income share held (as % of total income) in Third 20% of population in 2011?
Your answer should be very brief. -4.68. What is the difference between the Income share held (as % of total income) of Third 20% of population in 2008 and the Income share held (as % of total income) of Fourth 20% of population in 2011?
Your answer should be very brief. -6.52. What is the difference between the Income share held (as % of total income) in First 20% of population in 2008 and the Income share held (as % of total income) in Second 20% of population in 2012?
Offer a terse response. 29.25. What is the difference between the Income share held (as % of total income) of First 20% of population in 2008 and the Income share held (as % of total income) of Third 20% of population in 2012?
Give a very brief answer. 24.16. What is the difference between the Income share held (as % of total income) of First 20% of population in 2008 and the Income share held (as % of total income) of Fourth 20% of population in 2012?
Offer a terse response. 17.74. What is the difference between the Income share held (as % of total income) of Second 20% of population in 2008 and the Income share held (as % of total income) of Third 20% of population in 2012?
Ensure brevity in your answer.  -4.75. What is the difference between the Income share held (as % of total income) of Second 20% of population in 2008 and the Income share held (as % of total income) of Fourth 20% of population in 2012?
Your answer should be compact. -11.17. What is the difference between the Income share held (as % of total income) of Third 20% of population in 2008 and the Income share held (as % of total income) of Fourth 20% of population in 2012?
Keep it short and to the point. -6.39. What is the difference between the Income share held (as % of total income) in First 20% of population in 2009 and the Income share held (as % of total income) in Second 20% of population in 2010?
Your answer should be compact. 29.65. What is the difference between the Income share held (as % of total income) of First 20% of population in 2009 and the Income share held (as % of total income) of Third 20% of population in 2010?
Your answer should be compact. 24.8. What is the difference between the Income share held (as % of total income) of First 20% of population in 2009 and the Income share held (as % of total income) of Fourth 20% of population in 2010?
Offer a very short reply. 18.35. What is the difference between the Income share held (as % of total income) in Second 20% of population in 2009 and the Income share held (as % of total income) in Third 20% of population in 2010?
Provide a succinct answer. -4.64. What is the difference between the Income share held (as % of total income) of Second 20% of population in 2009 and the Income share held (as % of total income) of Fourth 20% of population in 2010?
Provide a succinct answer. -11.09. What is the difference between the Income share held (as % of total income) of Third 20% of population in 2009 and the Income share held (as % of total income) of Fourth 20% of population in 2010?
Make the answer very short. -6.38. What is the difference between the Income share held (as % of total income) in First 20% of population in 2009 and the Income share held (as % of total income) in Second 20% of population in 2011?
Provide a short and direct response. 29.84. What is the difference between the Income share held (as % of total income) in First 20% of population in 2009 and the Income share held (as % of total income) in Third 20% of population in 2011?
Offer a very short reply. 24.68. What is the difference between the Income share held (as % of total income) of First 20% of population in 2009 and the Income share held (as % of total income) of Fourth 20% of population in 2011?
Your answer should be very brief. 18.06. What is the difference between the Income share held (as % of total income) in Second 20% of population in 2009 and the Income share held (as % of total income) in Third 20% of population in 2011?
Give a very brief answer. -4.76. What is the difference between the Income share held (as % of total income) of Second 20% of population in 2009 and the Income share held (as % of total income) of Fourth 20% of population in 2011?
Provide a succinct answer. -11.38. What is the difference between the Income share held (as % of total income) in Third 20% of population in 2009 and the Income share held (as % of total income) in Fourth 20% of population in 2011?
Offer a very short reply. -6.67. What is the difference between the Income share held (as % of total income) in First 20% of population in 2009 and the Income share held (as % of total income) in Second 20% of population in 2012?
Keep it short and to the point. 29.7. What is the difference between the Income share held (as % of total income) in First 20% of population in 2009 and the Income share held (as % of total income) in Third 20% of population in 2012?
Provide a succinct answer. 24.61. What is the difference between the Income share held (as % of total income) in First 20% of population in 2009 and the Income share held (as % of total income) in Fourth 20% of population in 2012?
Provide a succinct answer. 18.19. What is the difference between the Income share held (as % of total income) in Second 20% of population in 2009 and the Income share held (as % of total income) in Third 20% of population in 2012?
Make the answer very short. -4.83. What is the difference between the Income share held (as % of total income) in Second 20% of population in 2009 and the Income share held (as % of total income) in Fourth 20% of population in 2012?
Provide a short and direct response. -11.25. What is the difference between the Income share held (as % of total income) of Third 20% of population in 2009 and the Income share held (as % of total income) of Fourth 20% of population in 2012?
Ensure brevity in your answer.  -6.54. What is the difference between the Income share held (as % of total income) of First 20% of population in 2010 and the Income share held (as % of total income) of Second 20% of population in 2011?
Provide a succinct answer. 30.11. What is the difference between the Income share held (as % of total income) in First 20% of population in 2010 and the Income share held (as % of total income) in Third 20% of population in 2011?
Provide a succinct answer. 24.95. What is the difference between the Income share held (as % of total income) of First 20% of population in 2010 and the Income share held (as % of total income) of Fourth 20% of population in 2011?
Give a very brief answer. 18.33. What is the difference between the Income share held (as % of total income) in Second 20% of population in 2010 and the Income share held (as % of total income) in Third 20% of population in 2011?
Your response must be concise. -4.97. What is the difference between the Income share held (as % of total income) of Second 20% of population in 2010 and the Income share held (as % of total income) of Fourth 20% of population in 2011?
Your response must be concise. -11.59. What is the difference between the Income share held (as % of total income) of Third 20% of population in 2010 and the Income share held (as % of total income) of Fourth 20% of population in 2011?
Offer a terse response. -6.74. What is the difference between the Income share held (as % of total income) in First 20% of population in 2010 and the Income share held (as % of total income) in Second 20% of population in 2012?
Ensure brevity in your answer.  29.97. What is the difference between the Income share held (as % of total income) in First 20% of population in 2010 and the Income share held (as % of total income) in Third 20% of population in 2012?
Ensure brevity in your answer.  24.88. What is the difference between the Income share held (as % of total income) of First 20% of population in 2010 and the Income share held (as % of total income) of Fourth 20% of population in 2012?
Your answer should be compact. 18.46. What is the difference between the Income share held (as % of total income) of Second 20% of population in 2010 and the Income share held (as % of total income) of Third 20% of population in 2012?
Offer a very short reply. -5.04. What is the difference between the Income share held (as % of total income) in Second 20% of population in 2010 and the Income share held (as % of total income) in Fourth 20% of population in 2012?
Your answer should be very brief. -11.46. What is the difference between the Income share held (as % of total income) in Third 20% of population in 2010 and the Income share held (as % of total income) in Fourth 20% of population in 2012?
Your answer should be very brief. -6.61. What is the difference between the Income share held (as % of total income) in First 20% of population in 2011 and the Income share held (as % of total income) in Second 20% of population in 2012?
Your response must be concise. 29.97. What is the difference between the Income share held (as % of total income) of First 20% of population in 2011 and the Income share held (as % of total income) of Third 20% of population in 2012?
Keep it short and to the point. 24.88. What is the difference between the Income share held (as % of total income) in First 20% of population in 2011 and the Income share held (as % of total income) in Fourth 20% of population in 2012?
Provide a succinct answer. 18.46. What is the difference between the Income share held (as % of total income) of Second 20% of population in 2011 and the Income share held (as % of total income) of Third 20% of population in 2012?
Keep it short and to the point. -5.23. What is the difference between the Income share held (as % of total income) of Second 20% of population in 2011 and the Income share held (as % of total income) of Fourth 20% of population in 2012?
Give a very brief answer. -11.65. What is the difference between the Income share held (as % of total income) in Third 20% of population in 2011 and the Income share held (as % of total income) in Fourth 20% of population in 2012?
Keep it short and to the point. -6.49. What is the average Income share held (as % of total income) in First 20% of population per year?
Provide a short and direct response. 40.96. What is the average Income share held (as % of total income) of Second 20% of population per year?
Keep it short and to the point. 12.31. What is the average Income share held (as % of total income) in Third 20% of population per year?
Offer a very short reply. 17.09. What is the average Income share held (as % of total income) of Fourth 20% of population per year?
Provide a short and direct response. 23.33. In the year 2004, what is the difference between the Income share held (as % of total income) of First 20% of population and Income share held (as % of total income) of Second 20% of population?
Your answer should be compact. 27.88. In the year 2004, what is the difference between the Income share held (as % of total income) in First 20% of population and Income share held (as % of total income) in Third 20% of population?
Give a very brief answer. 23.29. In the year 2004, what is the difference between the Income share held (as % of total income) in First 20% of population and Income share held (as % of total income) in Fourth 20% of population?
Offer a very short reply. 17.11. In the year 2004, what is the difference between the Income share held (as % of total income) in Second 20% of population and Income share held (as % of total income) in Third 20% of population?
Make the answer very short. -4.59. In the year 2004, what is the difference between the Income share held (as % of total income) in Second 20% of population and Income share held (as % of total income) in Fourth 20% of population?
Give a very brief answer. -10.77. In the year 2004, what is the difference between the Income share held (as % of total income) of Third 20% of population and Income share held (as % of total income) of Fourth 20% of population?
Offer a terse response. -6.18. In the year 2005, what is the difference between the Income share held (as % of total income) in First 20% of population and Income share held (as % of total income) in Second 20% of population?
Keep it short and to the point. 26.9. In the year 2005, what is the difference between the Income share held (as % of total income) of First 20% of population and Income share held (as % of total income) of Third 20% of population?
Provide a succinct answer. 22.28. In the year 2005, what is the difference between the Income share held (as % of total income) of First 20% of population and Income share held (as % of total income) of Fourth 20% of population?
Give a very brief answer. 16.46. In the year 2005, what is the difference between the Income share held (as % of total income) of Second 20% of population and Income share held (as % of total income) of Third 20% of population?
Your response must be concise. -4.62. In the year 2005, what is the difference between the Income share held (as % of total income) of Second 20% of population and Income share held (as % of total income) of Fourth 20% of population?
Your answer should be very brief. -10.44. In the year 2005, what is the difference between the Income share held (as % of total income) of Third 20% of population and Income share held (as % of total income) of Fourth 20% of population?
Your answer should be compact. -5.82. In the year 2006, what is the difference between the Income share held (as % of total income) of First 20% of population and Income share held (as % of total income) of Second 20% of population?
Provide a succinct answer. 27.04. In the year 2006, what is the difference between the Income share held (as % of total income) of First 20% of population and Income share held (as % of total income) of Third 20% of population?
Offer a very short reply. 22.43. In the year 2006, what is the difference between the Income share held (as % of total income) of First 20% of population and Income share held (as % of total income) of Fourth 20% of population?
Your answer should be compact. 16.49. In the year 2006, what is the difference between the Income share held (as % of total income) of Second 20% of population and Income share held (as % of total income) of Third 20% of population?
Offer a very short reply. -4.61. In the year 2006, what is the difference between the Income share held (as % of total income) of Second 20% of population and Income share held (as % of total income) of Fourth 20% of population?
Offer a very short reply. -10.55. In the year 2006, what is the difference between the Income share held (as % of total income) of Third 20% of population and Income share held (as % of total income) of Fourth 20% of population?
Make the answer very short. -5.94. In the year 2007, what is the difference between the Income share held (as % of total income) of First 20% of population and Income share held (as % of total income) of Second 20% of population?
Ensure brevity in your answer.  27.76. In the year 2007, what is the difference between the Income share held (as % of total income) of First 20% of population and Income share held (as % of total income) of Third 20% of population?
Offer a terse response. 23.1. In the year 2007, what is the difference between the Income share held (as % of total income) of First 20% of population and Income share held (as % of total income) of Fourth 20% of population?
Give a very brief answer. 16.93. In the year 2007, what is the difference between the Income share held (as % of total income) in Second 20% of population and Income share held (as % of total income) in Third 20% of population?
Your answer should be very brief. -4.66. In the year 2007, what is the difference between the Income share held (as % of total income) in Second 20% of population and Income share held (as % of total income) in Fourth 20% of population?
Your answer should be very brief. -10.83. In the year 2007, what is the difference between the Income share held (as % of total income) of Third 20% of population and Income share held (as % of total income) of Fourth 20% of population?
Your answer should be compact. -6.17. In the year 2008, what is the difference between the Income share held (as % of total income) of First 20% of population and Income share held (as % of total income) of Second 20% of population?
Your answer should be very brief. 28.91. In the year 2008, what is the difference between the Income share held (as % of total income) of First 20% of population and Income share held (as % of total income) of Third 20% of population?
Keep it short and to the point. 24.13. In the year 2008, what is the difference between the Income share held (as % of total income) of First 20% of population and Income share held (as % of total income) of Fourth 20% of population?
Provide a succinct answer. 17.94. In the year 2008, what is the difference between the Income share held (as % of total income) in Second 20% of population and Income share held (as % of total income) in Third 20% of population?
Provide a short and direct response. -4.78. In the year 2008, what is the difference between the Income share held (as % of total income) in Second 20% of population and Income share held (as % of total income) in Fourth 20% of population?
Offer a very short reply. -10.97. In the year 2008, what is the difference between the Income share held (as % of total income) of Third 20% of population and Income share held (as % of total income) of Fourth 20% of population?
Offer a terse response. -6.19. In the year 2009, what is the difference between the Income share held (as % of total income) of First 20% of population and Income share held (as % of total income) of Second 20% of population?
Provide a short and direct response. 29.44. In the year 2009, what is the difference between the Income share held (as % of total income) of First 20% of population and Income share held (as % of total income) of Third 20% of population?
Offer a very short reply. 24.73. In the year 2009, what is the difference between the Income share held (as % of total income) of Second 20% of population and Income share held (as % of total income) of Third 20% of population?
Ensure brevity in your answer.  -4.71. In the year 2009, what is the difference between the Income share held (as % of total income) of Second 20% of population and Income share held (as % of total income) of Fourth 20% of population?
Your answer should be very brief. -11.04. In the year 2009, what is the difference between the Income share held (as % of total income) of Third 20% of population and Income share held (as % of total income) of Fourth 20% of population?
Your answer should be compact. -6.33. In the year 2010, what is the difference between the Income share held (as % of total income) of First 20% of population and Income share held (as % of total income) of Second 20% of population?
Ensure brevity in your answer.  29.92. In the year 2010, what is the difference between the Income share held (as % of total income) in First 20% of population and Income share held (as % of total income) in Third 20% of population?
Provide a succinct answer. 25.07. In the year 2010, what is the difference between the Income share held (as % of total income) in First 20% of population and Income share held (as % of total income) in Fourth 20% of population?
Your answer should be compact. 18.62. In the year 2010, what is the difference between the Income share held (as % of total income) of Second 20% of population and Income share held (as % of total income) of Third 20% of population?
Your answer should be compact. -4.85. In the year 2010, what is the difference between the Income share held (as % of total income) of Second 20% of population and Income share held (as % of total income) of Fourth 20% of population?
Offer a terse response. -11.3. In the year 2010, what is the difference between the Income share held (as % of total income) in Third 20% of population and Income share held (as % of total income) in Fourth 20% of population?
Give a very brief answer. -6.45. In the year 2011, what is the difference between the Income share held (as % of total income) of First 20% of population and Income share held (as % of total income) of Second 20% of population?
Your answer should be very brief. 30.11. In the year 2011, what is the difference between the Income share held (as % of total income) in First 20% of population and Income share held (as % of total income) in Third 20% of population?
Offer a very short reply. 24.95. In the year 2011, what is the difference between the Income share held (as % of total income) of First 20% of population and Income share held (as % of total income) of Fourth 20% of population?
Give a very brief answer. 18.33. In the year 2011, what is the difference between the Income share held (as % of total income) of Second 20% of population and Income share held (as % of total income) of Third 20% of population?
Ensure brevity in your answer.  -5.16. In the year 2011, what is the difference between the Income share held (as % of total income) in Second 20% of population and Income share held (as % of total income) in Fourth 20% of population?
Give a very brief answer. -11.78. In the year 2011, what is the difference between the Income share held (as % of total income) in Third 20% of population and Income share held (as % of total income) in Fourth 20% of population?
Offer a terse response. -6.62. In the year 2012, what is the difference between the Income share held (as % of total income) of First 20% of population and Income share held (as % of total income) of Second 20% of population?
Make the answer very short. 29.89. In the year 2012, what is the difference between the Income share held (as % of total income) in First 20% of population and Income share held (as % of total income) in Third 20% of population?
Your answer should be very brief. 24.8. In the year 2012, what is the difference between the Income share held (as % of total income) in First 20% of population and Income share held (as % of total income) in Fourth 20% of population?
Make the answer very short. 18.38. In the year 2012, what is the difference between the Income share held (as % of total income) in Second 20% of population and Income share held (as % of total income) in Third 20% of population?
Offer a terse response. -5.09. In the year 2012, what is the difference between the Income share held (as % of total income) of Second 20% of population and Income share held (as % of total income) of Fourth 20% of population?
Provide a short and direct response. -11.51. In the year 2012, what is the difference between the Income share held (as % of total income) in Third 20% of population and Income share held (as % of total income) in Fourth 20% of population?
Your answer should be very brief. -6.42. What is the ratio of the Income share held (as % of total income) in First 20% of population in 2004 to that in 2005?
Your answer should be very brief. 1.02. What is the ratio of the Income share held (as % of total income) of Second 20% of population in 2004 to that in 2005?
Ensure brevity in your answer.  0.98. What is the ratio of the Income share held (as % of total income) in Third 20% of population in 2004 to that in 2005?
Keep it short and to the point. 0.98. What is the ratio of the Income share held (as % of total income) in Fourth 20% of population in 2004 to that in 2005?
Your answer should be compact. 1. What is the ratio of the Income share held (as % of total income) of First 20% of population in 2004 to that in 2006?
Your answer should be very brief. 1.02. What is the ratio of the Income share held (as % of total income) of Second 20% of population in 2004 to that in 2006?
Your answer should be very brief. 0.98. What is the ratio of the Income share held (as % of total income) in Third 20% of population in 2004 to that in 2006?
Provide a short and direct response. 0.99. What is the ratio of the Income share held (as % of total income) of Fourth 20% of population in 2004 to that in 2006?
Provide a succinct answer. 1. What is the ratio of the Income share held (as % of total income) of Third 20% of population in 2004 to that in 2007?
Your response must be concise. 0.99. What is the ratio of the Income share held (as % of total income) of Fourth 20% of population in 2004 to that in 2007?
Your response must be concise. 0.99. What is the ratio of the Income share held (as % of total income) in First 20% of population in 2004 to that in 2008?
Provide a short and direct response. 0.98. What is the ratio of the Income share held (as % of total income) in Second 20% of population in 2004 to that in 2008?
Offer a very short reply. 1.02. What is the ratio of the Income share held (as % of total income) of Third 20% of population in 2004 to that in 2008?
Offer a very short reply. 1. What is the ratio of the Income share held (as % of total income) in Fourth 20% of population in 2004 to that in 2008?
Offer a very short reply. 1. What is the ratio of the Income share held (as % of total income) of First 20% of population in 2004 to that in 2009?
Make the answer very short. 0.97. What is the ratio of the Income share held (as % of total income) in Third 20% of population in 2004 to that in 2009?
Give a very brief answer. 1.01. What is the ratio of the Income share held (as % of total income) in Fourth 20% of population in 2004 to that in 2009?
Your answer should be compact. 1. What is the ratio of the Income share held (as % of total income) of Second 20% of population in 2004 to that in 2010?
Make the answer very short. 1.04. What is the ratio of the Income share held (as % of total income) in Third 20% of population in 2004 to that in 2010?
Keep it short and to the point. 1.01. What is the ratio of the Income share held (as % of total income) of Fourth 20% of population in 2004 to that in 2010?
Give a very brief answer. 1. What is the ratio of the Income share held (as % of total income) of First 20% of population in 2004 to that in 2011?
Make the answer very short. 0.96. What is the ratio of the Income share held (as % of total income) in Second 20% of population in 2004 to that in 2011?
Your answer should be compact. 1.06. What is the ratio of the Income share held (as % of total income) in First 20% of population in 2004 to that in 2012?
Offer a terse response. 0.96. What is the ratio of the Income share held (as % of total income) of Second 20% of population in 2004 to that in 2012?
Ensure brevity in your answer.  1.05. What is the ratio of the Income share held (as % of total income) of Second 20% of population in 2005 to that in 2006?
Your response must be concise. 1. What is the ratio of the Income share held (as % of total income) of First 20% of population in 2005 to that in 2007?
Keep it short and to the point. 0.98. What is the ratio of the Income share held (as % of total income) of Second 20% of population in 2005 to that in 2007?
Provide a short and direct response. 1.01. What is the ratio of the Income share held (as % of total income) of Third 20% of population in 2005 to that in 2007?
Your answer should be very brief. 1.01. What is the ratio of the Income share held (as % of total income) in Fourth 20% of population in 2005 to that in 2007?
Keep it short and to the point. 0.99. What is the ratio of the Income share held (as % of total income) in First 20% of population in 2005 to that in 2008?
Offer a terse response. 0.96. What is the ratio of the Income share held (as % of total income) in Second 20% of population in 2005 to that in 2008?
Your answer should be very brief. 1.04. What is the ratio of the Income share held (as % of total income) of Third 20% of population in 2005 to that in 2008?
Give a very brief answer. 1.02. What is the ratio of the Income share held (as % of total income) of Fourth 20% of population in 2005 to that in 2008?
Provide a succinct answer. 1. What is the ratio of the Income share held (as % of total income) in First 20% of population in 2005 to that in 2009?
Give a very brief answer. 0.95. What is the ratio of the Income share held (as % of total income) in Second 20% of population in 2005 to that in 2009?
Offer a terse response. 1.05. What is the ratio of the Income share held (as % of total income) of Third 20% of population in 2005 to that in 2009?
Give a very brief answer. 1.03. What is the ratio of the Income share held (as % of total income) in Fourth 20% of population in 2005 to that in 2009?
Keep it short and to the point. 1. What is the ratio of the Income share held (as % of total income) in First 20% of population in 2005 to that in 2010?
Make the answer very short. 0.95. What is the ratio of the Income share held (as % of total income) in Second 20% of population in 2005 to that in 2010?
Make the answer very short. 1.07. What is the ratio of the Income share held (as % of total income) in Third 20% of population in 2005 to that in 2010?
Offer a terse response. 1.03. What is the ratio of the Income share held (as % of total income) of First 20% of population in 2005 to that in 2011?
Ensure brevity in your answer.  0.95. What is the ratio of the Income share held (as % of total income) in Second 20% of population in 2005 to that in 2011?
Give a very brief answer. 1.08. What is the ratio of the Income share held (as % of total income) in Third 20% of population in 2005 to that in 2011?
Make the answer very short. 1.03. What is the ratio of the Income share held (as % of total income) of Fourth 20% of population in 2005 to that in 2011?
Offer a very short reply. 0.98. What is the ratio of the Income share held (as % of total income) in First 20% of population in 2005 to that in 2012?
Your answer should be very brief. 0.95. What is the ratio of the Income share held (as % of total income) in Second 20% of population in 2005 to that in 2012?
Your response must be concise. 1.07. What is the ratio of the Income share held (as % of total income) of Third 20% of population in 2005 to that in 2012?
Keep it short and to the point. 1.02. What is the ratio of the Income share held (as % of total income) of Fourth 20% of population in 2005 to that in 2012?
Offer a terse response. 0.99. What is the ratio of the Income share held (as % of total income) of First 20% of population in 2006 to that in 2007?
Ensure brevity in your answer.  0.98. What is the ratio of the Income share held (as % of total income) of Second 20% of population in 2006 to that in 2007?
Your response must be concise. 1.01. What is the ratio of the Income share held (as % of total income) in Third 20% of population in 2006 to that in 2007?
Offer a very short reply. 1. What is the ratio of the Income share held (as % of total income) in Second 20% of population in 2006 to that in 2008?
Make the answer very short. 1.03. What is the ratio of the Income share held (as % of total income) of Third 20% of population in 2006 to that in 2008?
Provide a short and direct response. 1.02. What is the ratio of the Income share held (as % of total income) in Fourth 20% of population in 2006 to that in 2008?
Your answer should be compact. 1. What is the ratio of the Income share held (as % of total income) of First 20% of population in 2006 to that in 2009?
Your answer should be very brief. 0.95. What is the ratio of the Income share held (as % of total income) of Second 20% of population in 2006 to that in 2009?
Offer a very short reply. 1.04. What is the ratio of the Income share held (as % of total income) in Third 20% of population in 2006 to that in 2009?
Your answer should be very brief. 1.02. What is the ratio of the Income share held (as % of total income) in Fourth 20% of population in 2006 to that in 2009?
Ensure brevity in your answer.  1. What is the ratio of the Income share held (as % of total income) in First 20% of population in 2006 to that in 2010?
Your answer should be very brief. 0.95. What is the ratio of the Income share held (as % of total income) in Second 20% of population in 2006 to that in 2010?
Your answer should be compact. 1.06. What is the ratio of the Income share held (as % of total income) in Third 20% of population in 2006 to that in 2010?
Provide a short and direct response. 1.03. What is the ratio of the Income share held (as % of total income) of First 20% of population in 2006 to that in 2011?
Your answer should be very brief. 0.95. What is the ratio of the Income share held (as % of total income) in Second 20% of population in 2006 to that in 2011?
Your response must be concise. 1.08. What is the ratio of the Income share held (as % of total income) in Third 20% of population in 2006 to that in 2011?
Your response must be concise. 1.02. What is the ratio of the Income share held (as % of total income) of Fourth 20% of population in 2006 to that in 2011?
Offer a terse response. 0.99. What is the ratio of the Income share held (as % of total income) in First 20% of population in 2006 to that in 2012?
Give a very brief answer. 0.95. What is the ratio of the Income share held (as % of total income) of Second 20% of population in 2006 to that in 2012?
Offer a very short reply. 1.06. What is the ratio of the Income share held (as % of total income) of Third 20% of population in 2006 to that in 2012?
Your response must be concise. 1.02. What is the ratio of the Income share held (as % of total income) in Fourth 20% of population in 2006 to that in 2012?
Provide a short and direct response. 0.99. What is the ratio of the Income share held (as % of total income) in First 20% of population in 2007 to that in 2008?
Your answer should be very brief. 0.98. What is the ratio of the Income share held (as % of total income) in Second 20% of population in 2007 to that in 2008?
Offer a terse response. 1.03. What is the ratio of the Income share held (as % of total income) in Third 20% of population in 2007 to that in 2008?
Make the answer very short. 1.01. What is the ratio of the Income share held (as % of total income) in Fourth 20% of population in 2007 to that in 2008?
Your response must be concise. 1.01. What is the ratio of the Income share held (as % of total income) of First 20% of population in 2007 to that in 2009?
Ensure brevity in your answer.  0.97. What is the ratio of the Income share held (as % of total income) of Second 20% of population in 2007 to that in 2009?
Provide a short and direct response. 1.03. What is the ratio of the Income share held (as % of total income) in Third 20% of population in 2007 to that in 2009?
Make the answer very short. 1.02. What is the ratio of the Income share held (as % of total income) of Fourth 20% of population in 2007 to that in 2009?
Make the answer very short. 1.01. What is the ratio of the Income share held (as % of total income) of First 20% of population in 2007 to that in 2010?
Your response must be concise. 0.96. What is the ratio of the Income share held (as % of total income) in Second 20% of population in 2007 to that in 2010?
Ensure brevity in your answer.  1.05. What is the ratio of the Income share held (as % of total income) in Third 20% of population in 2007 to that in 2010?
Make the answer very short. 1.03. What is the ratio of the Income share held (as % of total income) of Fourth 20% of population in 2007 to that in 2010?
Keep it short and to the point. 1.01. What is the ratio of the Income share held (as % of total income) in First 20% of population in 2007 to that in 2011?
Your answer should be compact. 0.96. What is the ratio of the Income share held (as % of total income) of Second 20% of population in 2007 to that in 2011?
Your response must be concise. 1.07. What is the ratio of the Income share held (as % of total income) in Third 20% of population in 2007 to that in 2011?
Make the answer very short. 1.02. What is the ratio of the Income share held (as % of total income) of First 20% of population in 2007 to that in 2012?
Offer a very short reply. 0.97. What is the ratio of the Income share held (as % of total income) of Second 20% of population in 2007 to that in 2012?
Keep it short and to the point. 1.06. What is the ratio of the Income share held (as % of total income) of Third 20% of population in 2007 to that in 2012?
Make the answer very short. 1.01. What is the ratio of the Income share held (as % of total income) of Fourth 20% of population in 2007 to that in 2012?
Your response must be concise. 1. What is the ratio of the Income share held (as % of total income) in First 20% of population in 2008 to that in 2009?
Keep it short and to the point. 0.99. What is the ratio of the Income share held (as % of total income) in Second 20% of population in 2008 to that in 2009?
Provide a succinct answer. 1.01. What is the ratio of the Income share held (as % of total income) of Third 20% of population in 2008 to that in 2009?
Your answer should be very brief. 1.01. What is the ratio of the Income share held (as % of total income) of First 20% of population in 2008 to that in 2010?
Give a very brief answer. 0.98. What is the ratio of the Income share held (as % of total income) of Second 20% of population in 2008 to that in 2010?
Offer a very short reply. 1.02. What is the ratio of the Income share held (as % of total income) in Third 20% of population in 2008 to that in 2010?
Offer a very short reply. 1.01. What is the ratio of the Income share held (as % of total income) in First 20% of population in 2008 to that in 2011?
Your answer should be compact. 0.98. What is the ratio of the Income share held (as % of total income) in Second 20% of population in 2008 to that in 2011?
Keep it short and to the point. 1.04. What is the ratio of the Income share held (as % of total income) in Third 20% of population in 2008 to that in 2011?
Provide a short and direct response. 1.01. What is the ratio of the Income share held (as % of total income) of First 20% of population in 2008 to that in 2012?
Give a very brief answer. 0.98. What is the ratio of the Income share held (as % of total income) in Second 20% of population in 2008 to that in 2012?
Your answer should be compact. 1.03. What is the ratio of the Income share held (as % of total income) in Fourth 20% of population in 2008 to that in 2012?
Your answer should be compact. 0.99. What is the ratio of the Income share held (as % of total income) in Second 20% of population in 2009 to that in 2010?
Your response must be concise. 1.02. What is the ratio of the Income share held (as % of total income) of Second 20% of population in 2009 to that in 2011?
Offer a very short reply. 1.03. What is the ratio of the Income share held (as % of total income) of Fourth 20% of population in 2009 to that in 2011?
Your answer should be very brief. 0.99. What is the ratio of the Income share held (as % of total income) in Second 20% of population in 2009 to that in 2012?
Your answer should be very brief. 1.02. What is the ratio of the Income share held (as % of total income) of First 20% of population in 2010 to that in 2011?
Your response must be concise. 1. What is the ratio of the Income share held (as % of total income) of Second 20% of population in 2010 to that in 2011?
Provide a short and direct response. 1.02. What is the ratio of the Income share held (as % of total income) in Fourth 20% of population in 2010 to that in 2011?
Your answer should be compact. 0.99. What is the ratio of the Income share held (as % of total income) of First 20% of population in 2010 to that in 2012?
Your answer should be compact. 1. What is the ratio of the Income share held (as % of total income) in Second 20% of population in 2010 to that in 2012?
Provide a short and direct response. 1. What is the ratio of the Income share held (as % of total income) in Third 20% of population in 2010 to that in 2012?
Provide a succinct answer. 0.99. What is the ratio of the Income share held (as % of total income) of First 20% of population in 2011 to that in 2012?
Make the answer very short. 1. What is the ratio of the Income share held (as % of total income) in Second 20% of population in 2011 to that in 2012?
Your response must be concise. 0.99. What is the ratio of the Income share held (as % of total income) of Third 20% of population in 2011 to that in 2012?
Offer a terse response. 1. What is the difference between the highest and the second highest Income share held (as % of total income) in First 20% of population?
Your answer should be very brief. 0. What is the difference between the highest and the second highest Income share held (as % of total income) in Third 20% of population?
Your answer should be compact. 0.07. What is the difference between the highest and the second highest Income share held (as % of total income) in Fourth 20% of population?
Your answer should be compact. 0.13. What is the difference between the highest and the lowest Income share held (as % of total income) of First 20% of population?
Offer a very short reply. 2.24. What is the difference between the highest and the lowest Income share held (as % of total income) in Second 20% of population?
Ensure brevity in your answer.  0.97. What is the difference between the highest and the lowest Income share held (as % of total income) in Third 20% of population?
Make the answer very short. 0.55. What is the difference between the highest and the lowest Income share held (as % of total income) of Fourth 20% of population?
Give a very brief answer. 0.37. 